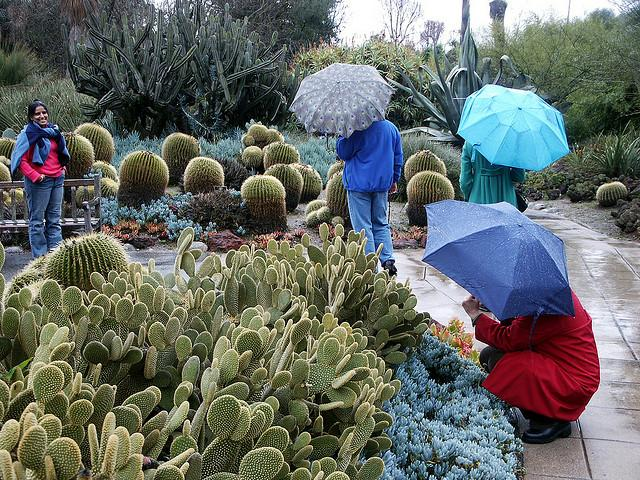These types of plants are good in what environment? desert 